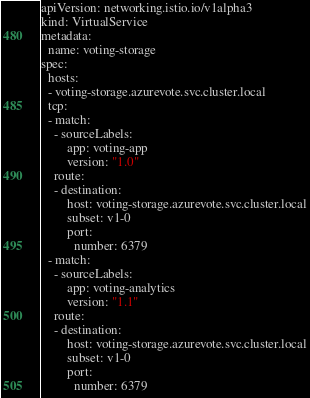<code> <loc_0><loc_0><loc_500><loc_500><_YAML_>apiVersion: networking.istio.io/v1alpha3
kind: VirtualService
metadata:
  name: voting-storage
spec:
  hosts:
  - voting-storage.azurevote.svc.cluster.local
  tcp:
  - match:
    - sourceLabels:
        app: voting-app
        version: "1.0"
    route:
    - destination:
        host: voting-storage.azurevote.svc.cluster.local
        subset: v1-0
        port:
          number: 6379
  - match:
    - sourceLabels:
        app: voting-analytics
        version: "1.1"
    route:
    - destination:
        host: voting-storage.azurevote.svc.cluster.local
        subset: v1-0
        port:
          number: 6379
</code> 